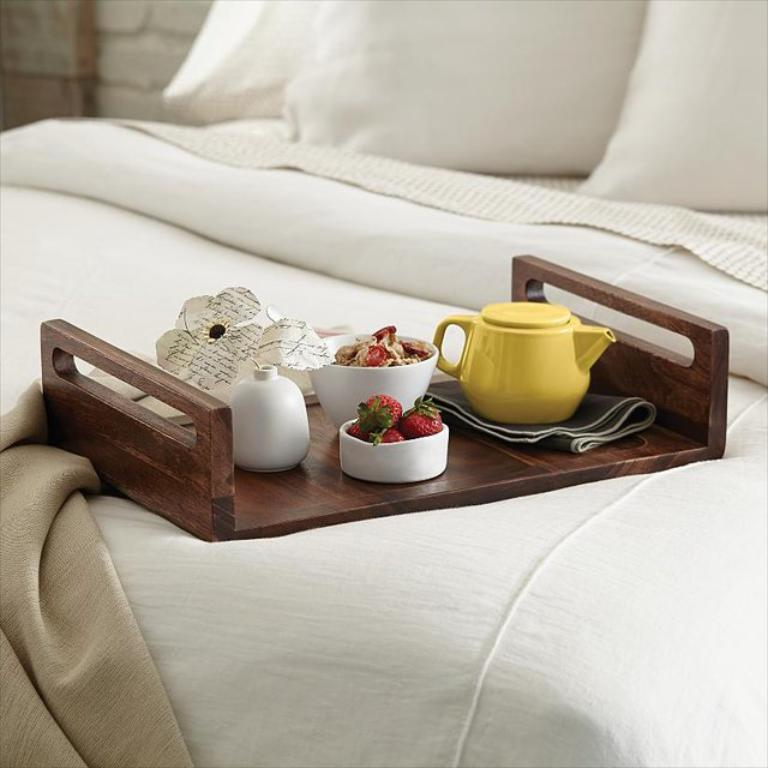What type of items can be seen in the image? There are eatables in the image. Where are the eatables placed? The eatables are placed on a white bed. What type of whip is used to hear the eatables in the image? There is no whip or hearing involved in the image; it simply displays eatables placed on a white bed. 